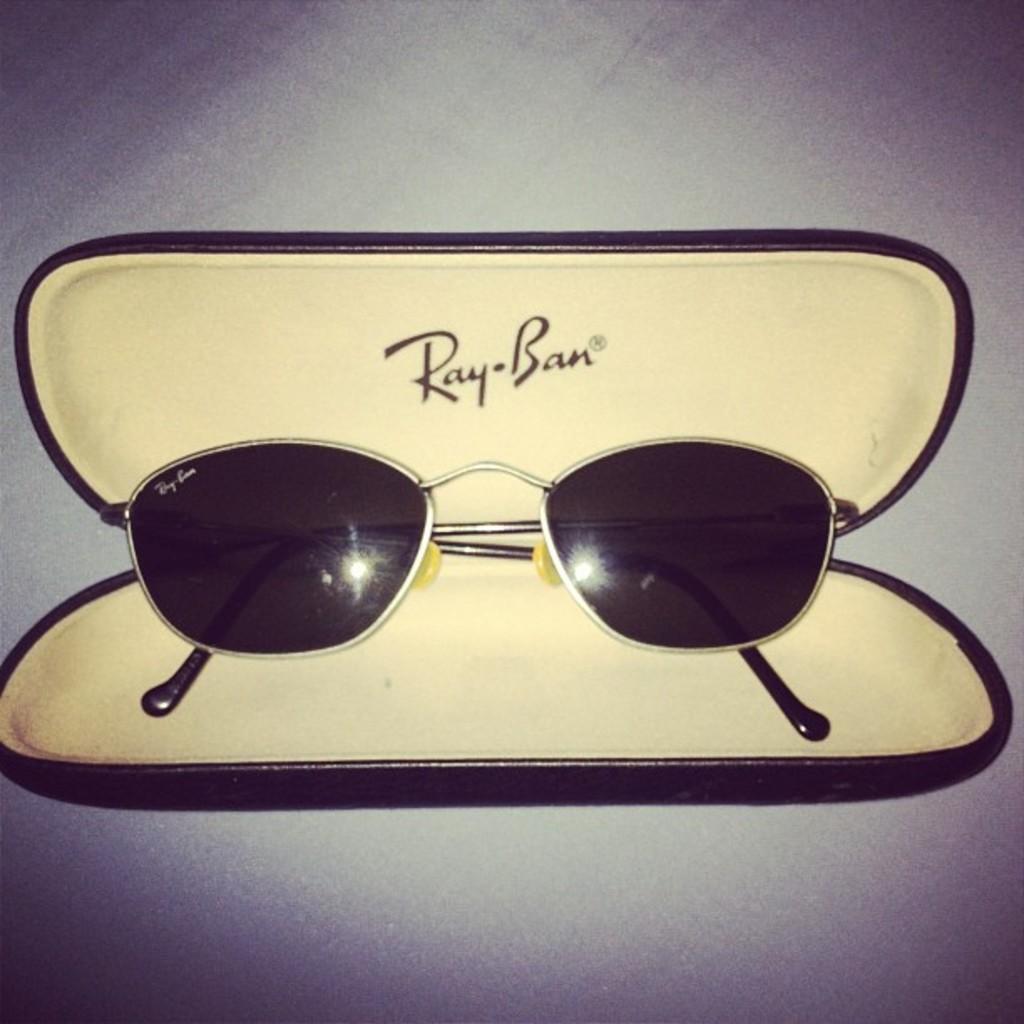How would you summarize this image in a sentence or two? In this image there is sun glass in a box. 